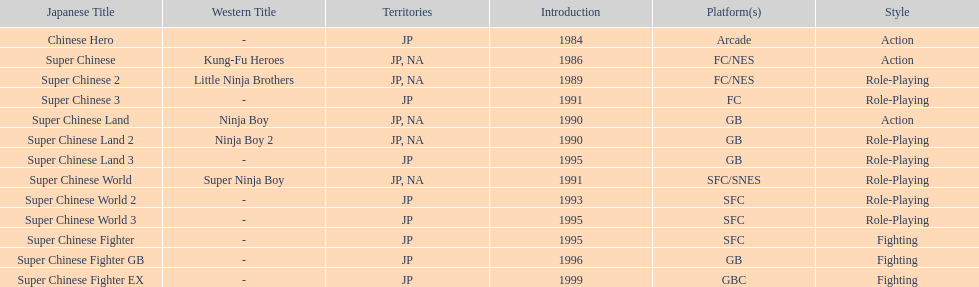How many action games were released in north america? 2. 